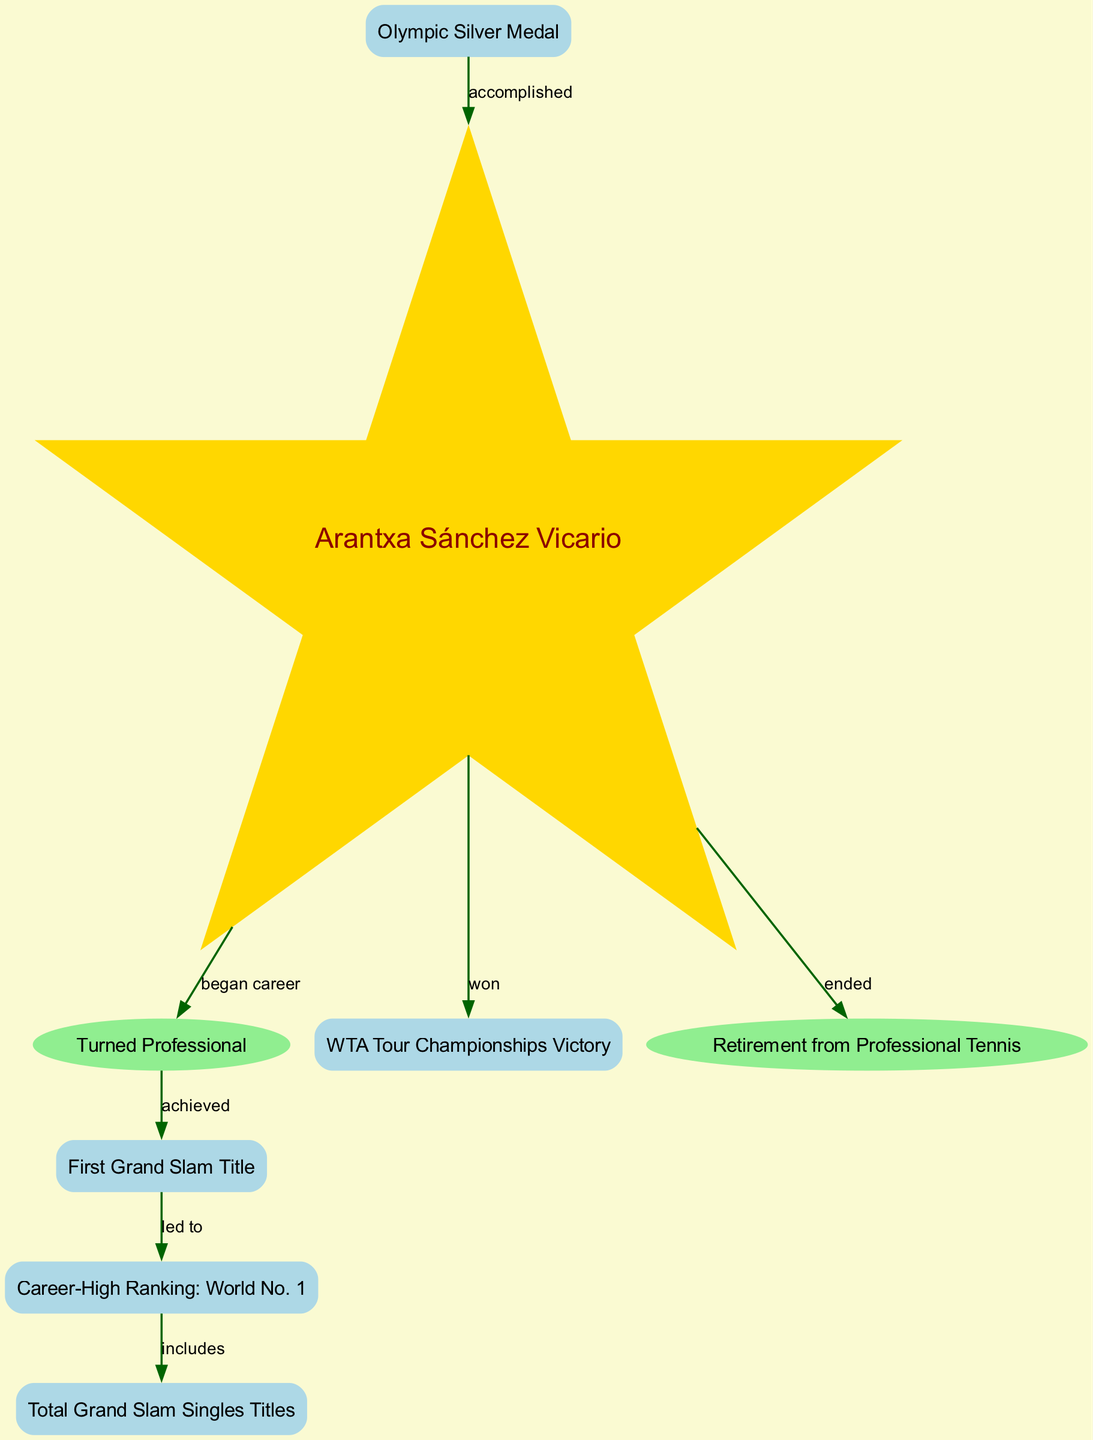What is Arantxa Sánchez Vicario's first major achievement in her career? The diagram indicates that the first major achievement after turning professional is the "First Grand Slam Title," which shows the flow of her progress in the graph.
Answer: First Grand Slam Title What did Arantxa Sánchez Vicario accomplish after winning her first Grand Slam title? According to the diagram, winning the first Grand Slam title led her to achieve a career-high ranking of "World No. 1," indicating the sequence of achievements.
Answer: World No. 1 How many total Grand Slam singles titles does Arantxa Sánchez Vicario have? The diagram shows that her career-high ranking of "World No. 1" includes the "Total Grand Slam Singles Titles," which suggests that the value is related to this achievement.
Answer: Total Grand Slam Singles Titles Which achievement is associated with winning the Olympic Silver Medal? The edge labeled "accomplished" connects the Olympic Silver Medal to Arantxa Sánchez Vicario, indicating that this is a separate notable achievement in her career.
Answer: Olympic Silver Medal What did Arantxa Sánchez Vicario win before retiring from professional tennis? The diagram outlines an edge that shows she "won" the WTA Tour Championships indicating that this victory is part of her notable career milestones prior to retirement.
Answer: WTA Tour Championships Victory 